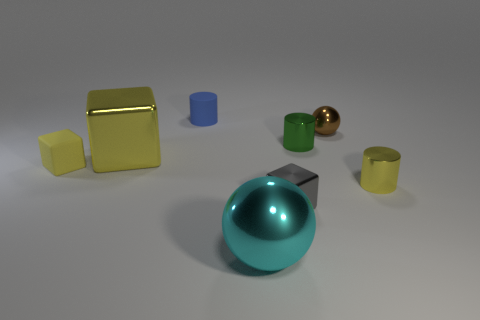Is the rubber cube the same color as the large cube?
Your answer should be very brief. Yes. How many things are both right of the tiny blue cylinder and behind the cyan metallic sphere?
Provide a short and direct response. 4. There is a shiny thing that is on the left side of the cylinder behind the small green metal cylinder; what number of yellow cubes are in front of it?
Your answer should be very brief. 1. There is another block that is the same color as the matte block; what size is it?
Provide a succinct answer. Large. The gray thing has what shape?
Your response must be concise. Cube. What number of gray objects have the same material as the yellow cylinder?
Keep it short and to the point. 1. There is a small block that is made of the same material as the tiny green thing; what is its color?
Your answer should be compact. Gray. Do the gray shiny cube and the cylinder that is right of the green cylinder have the same size?
Make the answer very short. Yes. There is a tiny block in front of the small yellow thing right of the metallic cylinder that is left of the tiny brown shiny object; what is its material?
Offer a very short reply. Metal. What number of objects are small gray objects or small yellow matte blocks?
Your response must be concise. 2. 